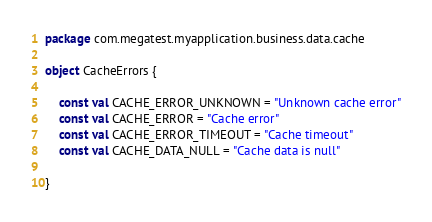<code> <loc_0><loc_0><loc_500><loc_500><_Kotlin_>package com.megatest.myapplication.business.data.cache

object CacheErrors {

    const val CACHE_ERROR_UNKNOWN = "Unknown cache error"
    const val CACHE_ERROR = "Cache error"
    const val CACHE_ERROR_TIMEOUT = "Cache timeout"
    const val CACHE_DATA_NULL = "Cache data is null"

}</code> 